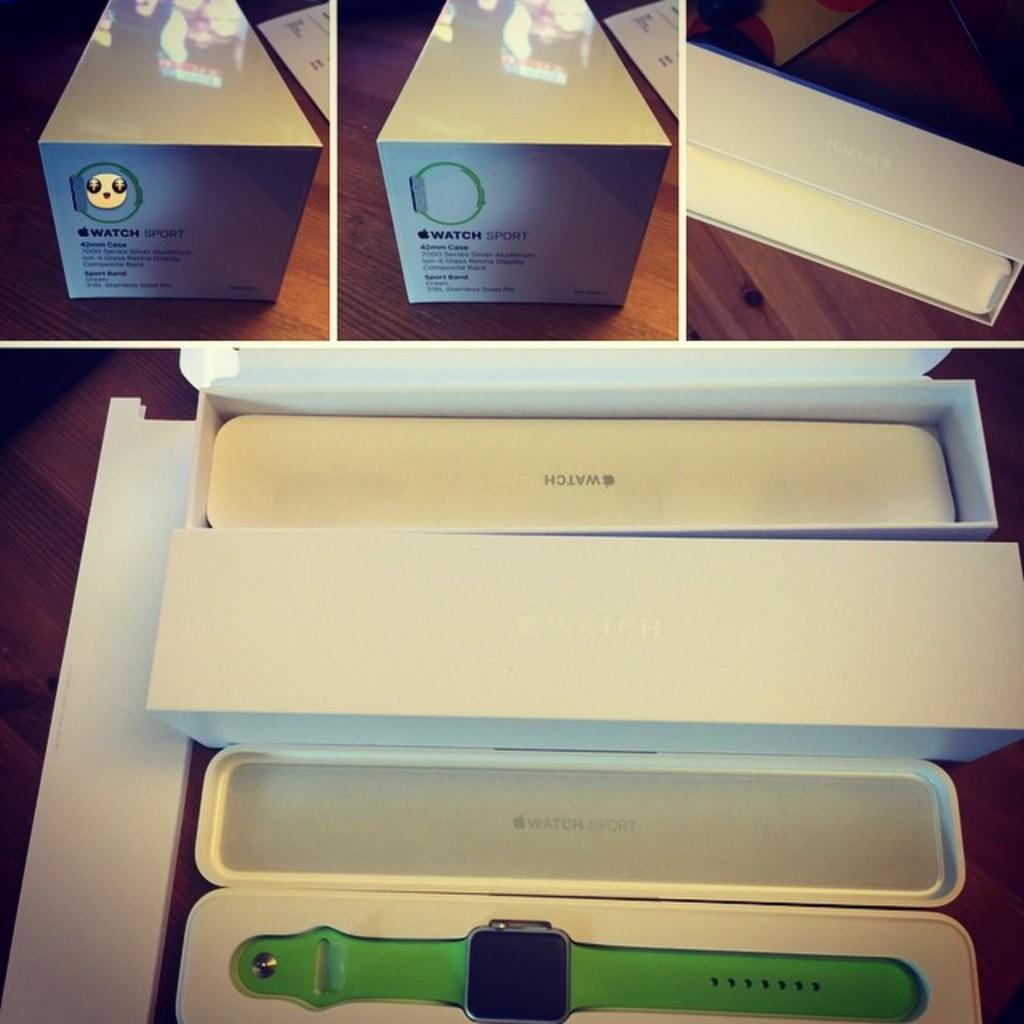<image>
Describe the image concisely. An open case of an Apple Watch with a green strap 